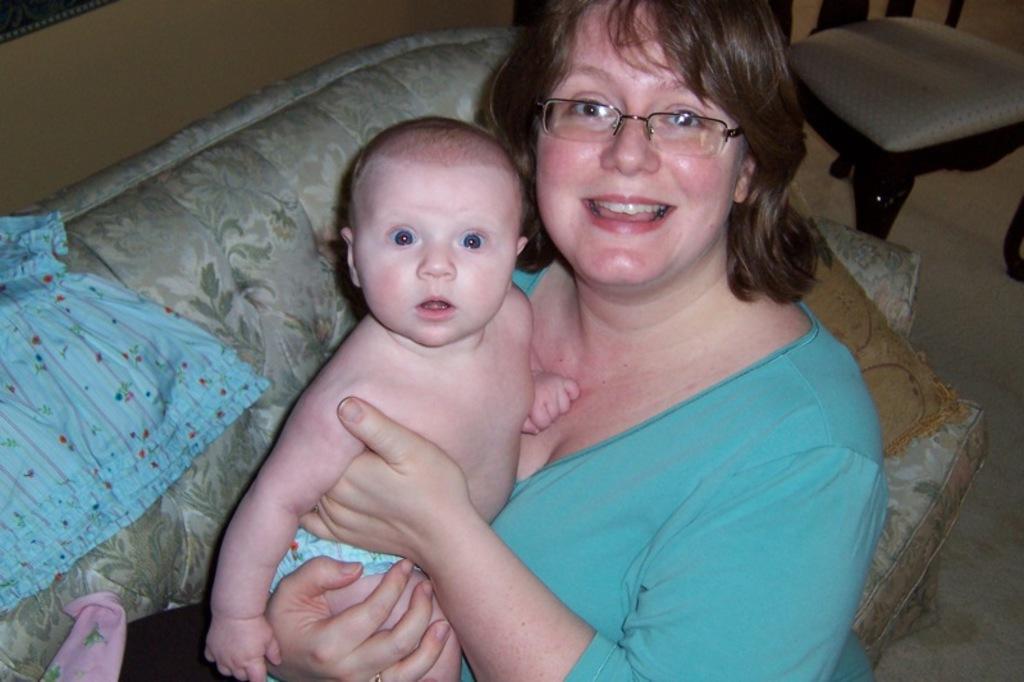Describe this image in one or two sentences. In the foreground of this image, there is a woman carrying a baby on a couch and there is a blue colored cloth on the couch. In the background, there is a chair on the floor. 